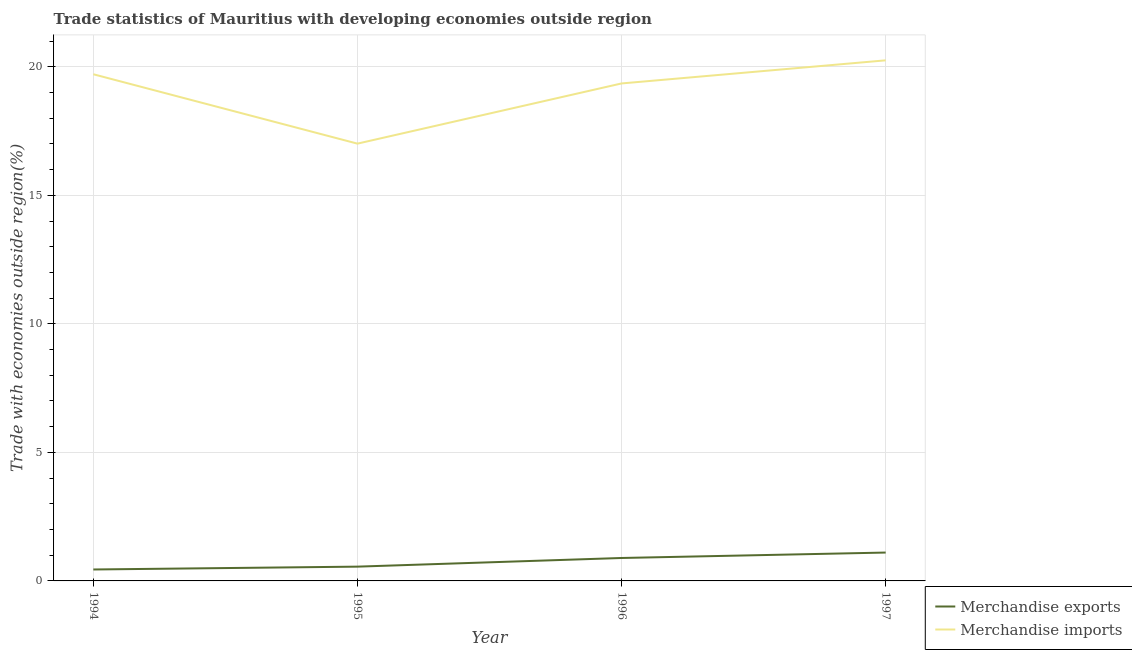What is the merchandise exports in 1996?
Provide a short and direct response. 0.89. Across all years, what is the maximum merchandise imports?
Provide a short and direct response. 20.25. Across all years, what is the minimum merchandise exports?
Make the answer very short. 0.44. In which year was the merchandise imports maximum?
Keep it short and to the point. 1997. In which year was the merchandise imports minimum?
Offer a very short reply. 1995. What is the total merchandise exports in the graph?
Provide a succinct answer. 3. What is the difference between the merchandise imports in 1994 and that in 1995?
Provide a succinct answer. 2.7. What is the difference between the merchandise imports in 1997 and the merchandise exports in 1995?
Your answer should be very brief. 19.7. What is the average merchandise exports per year?
Provide a short and direct response. 0.75. In the year 1994, what is the difference between the merchandise exports and merchandise imports?
Offer a very short reply. -19.27. In how many years, is the merchandise imports greater than 17 %?
Offer a very short reply. 4. What is the ratio of the merchandise exports in 1995 to that in 1997?
Offer a terse response. 0.5. What is the difference between the highest and the second highest merchandise imports?
Your response must be concise. 0.54. What is the difference between the highest and the lowest merchandise exports?
Your response must be concise. 0.66. Is the sum of the merchandise exports in 1994 and 1996 greater than the maximum merchandise imports across all years?
Ensure brevity in your answer.  No. Is the merchandise imports strictly greater than the merchandise exports over the years?
Keep it short and to the point. Yes. Is the merchandise imports strictly less than the merchandise exports over the years?
Offer a very short reply. No. What is the difference between two consecutive major ticks on the Y-axis?
Make the answer very short. 5. How many legend labels are there?
Your answer should be compact. 2. What is the title of the graph?
Ensure brevity in your answer.  Trade statistics of Mauritius with developing economies outside region. Does "Mineral" appear as one of the legend labels in the graph?
Provide a short and direct response. No. What is the label or title of the X-axis?
Provide a succinct answer. Year. What is the label or title of the Y-axis?
Keep it short and to the point. Trade with economies outside region(%). What is the Trade with economies outside region(%) of Merchandise exports in 1994?
Provide a short and direct response. 0.44. What is the Trade with economies outside region(%) of Merchandise imports in 1994?
Keep it short and to the point. 19.71. What is the Trade with economies outside region(%) of Merchandise exports in 1995?
Make the answer very short. 0.56. What is the Trade with economies outside region(%) of Merchandise imports in 1995?
Provide a succinct answer. 17.01. What is the Trade with economies outside region(%) of Merchandise exports in 1996?
Provide a short and direct response. 0.89. What is the Trade with economies outside region(%) of Merchandise imports in 1996?
Your answer should be compact. 19.35. What is the Trade with economies outside region(%) of Merchandise exports in 1997?
Provide a short and direct response. 1.1. What is the Trade with economies outside region(%) of Merchandise imports in 1997?
Offer a terse response. 20.25. Across all years, what is the maximum Trade with economies outside region(%) in Merchandise exports?
Ensure brevity in your answer.  1.1. Across all years, what is the maximum Trade with economies outside region(%) of Merchandise imports?
Your response must be concise. 20.25. Across all years, what is the minimum Trade with economies outside region(%) of Merchandise exports?
Your response must be concise. 0.44. Across all years, what is the minimum Trade with economies outside region(%) of Merchandise imports?
Provide a short and direct response. 17.01. What is the total Trade with economies outside region(%) of Merchandise exports in the graph?
Your answer should be compact. 3. What is the total Trade with economies outside region(%) in Merchandise imports in the graph?
Ensure brevity in your answer.  76.33. What is the difference between the Trade with economies outside region(%) in Merchandise exports in 1994 and that in 1995?
Keep it short and to the point. -0.11. What is the difference between the Trade with economies outside region(%) in Merchandise imports in 1994 and that in 1995?
Provide a succinct answer. 2.7. What is the difference between the Trade with economies outside region(%) in Merchandise exports in 1994 and that in 1996?
Ensure brevity in your answer.  -0.45. What is the difference between the Trade with economies outside region(%) of Merchandise imports in 1994 and that in 1996?
Keep it short and to the point. 0.36. What is the difference between the Trade with economies outside region(%) of Merchandise exports in 1994 and that in 1997?
Your answer should be compact. -0.66. What is the difference between the Trade with economies outside region(%) of Merchandise imports in 1994 and that in 1997?
Your response must be concise. -0.54. What is the difference between the Trade with economies outside region(%) of Merchandise exports in 1995 and that in 1996?
Provide a succinct answer. -0.34. What is the difference between the Trade with economies outside region(%) in Merchandise imports in 1995 and that in 1996?
Provide a short and direct response. -2.34. What is the difference between the Trade with economies outside region(%) of Merchandise exports in 1995 and that in 1997?
Your response must be concise. -0.55. What is the difference between the Trade with economies outside region(%) in Merchandise imports in 1995 and that in 1997?
Your answer should be very brief. -3.24. What is the difference between the Trade with economies outside region(%) in Merchandise exports in 1996 and that in 1997?
Offer a very short reply. -0.21. What is the difference between the Trade with economies outside region(%) of Merchandise imports in 1996 and that in 1997?
Your answer should be very brief. -0.9. What is the difference between the Trade with economies outside region(%) of Merchandise exports in 1994 and the Trade with economies outside region(%) of Merchandise imports in 1995?
Provide a succinct answer. -16.57. What is the difference between the Trade with economies outside region(%) of Merchandise exports in 1994 and the Trade with economies outside region(%) of Merchandise imports in 1996?
Offer a very short reply. -18.91. What is the difference between the Trade with economies outside region(%) in Merchandise exports in 1994 and the Trade with economies outside region(%) in Merchandise imports in 1997?
Keep it short and to the point. -19.81. What is the difference between the Trade with economies outside region(%) of Merchandise exports in 1995 and the Trade with economies outside region(%) of Merchandise imports in 1996?
Make the answer very short. -18.8. What is the difference between the Trade with economies outside region(%) in Merchandise exports in 1995 and the Trade with economies outside region(%) in Merchandise imports in 1997?
Your response must be concise. -19.7. What is the difference between the Trade with economies outside region(%) in Merchandise exports in 1996 and the Trade with economies outside region(%) in Merchandise imports in 1997?
Your answer should be compact. -19.36. What is the average Trade with economies outside region(%) of Merchandise exports per year?
Offer a terse response. 0.75. What is the average Trade with economies outside region(%) in Merchandise imports per year?
Ensure brevity in your answer.  19.08. In the year 1994, what is the difference between the Trade with economies outside region(%) of Merchandise exports and Trade with economies outside region(%) of Merchandise imports?
Give a very brief answer. -19.27. In the year 1995, what is the difference between the Trade with economies outside region(%) in Merchandise exports and Trade with economies outside region(%) in Merchandise imports?
Your answer should be very brief. -16.46. In the year 1996, what is the difference between the Trade with economies outside region(%) in Merchandise exports and Trade with economies outside region(%) in Merchandise imports?
Keep it short and to the point. -18.46. In the year 1997, what is the difference between the Trade with economies outside region(%) of Merchandise exports and Trade with economies outside region(%) of Merchandise imports?
Provide a succinct answer. -19.15. What is the ratio of the Trade with economies outside region(%) in Merchandise imports in 1994 to that in 1995?
Offer a terse response. 1.16. What is the ratio of the Trade with economies outside region(%) in Merchandise exports in 1994 to that in 1996?
Your answer should be compact. 0.5. What is the ratio of the Trade with economies outside region(%) of Merchandise imports in 1994 to that in 1996?
Provide a short and direct response. 1.02. What is the ratio of the Trade with economies outside region(%) of Merchandise exports in 1994 to that in 1997?
Your answer should be compact. 0.4. What is the ratio of the Trade with economies outside region(%) in Merchandise imports in 1994 to that in 1997?
Your response must be concise. 0.97. What is the ratio of the Trade with economies outside region(%) in Merchandise exports in 1995 to that in 1996?
Offer a terse response. 0.62. What is the ratio of the Trade with economies outside region(%) of Merchandise imports in 1995 to that in 1996?
Your answer should be very brief. 0.88. What is the ratio of the Trade with economies outside region(%) in Merchandise exports in 1995 to that in 1997?
Your answer should be very brief. 0.5. What is the ratio of the Trade with economies outside region(%) of Merchandise imports in 1995 to that in 1997?
Give a very brief answer. 0.84. What is the ratio of the Trade with economies outside region(%) of Merchandise exports in 1996 to that in 1997?
Offer a very short reply. 0.81. What is the ratio of the Trade with economies outside region(%) in Merchandise imports in 1996 to that in 1997?
Your response must be concise. 0.96. What is the difference between the highest and the second highest Trade with economies outside region(%) in Merchandise exports?
Your response must be concise. 0.21. What is the difference between the highest and the second highest Trade with economies outside region(%) in Merchandise imports?
Your answer should be very brief. 0.54. What is the difference between the highest and the lowest Trade with economies outside region(%) in Merchandise exports?
Your response must be concise. 0.66. What is the difference between the highest and the lowest Trade with economies outside region(%) of Merchandise imports?
Keep it short and to the point. 3.24. 